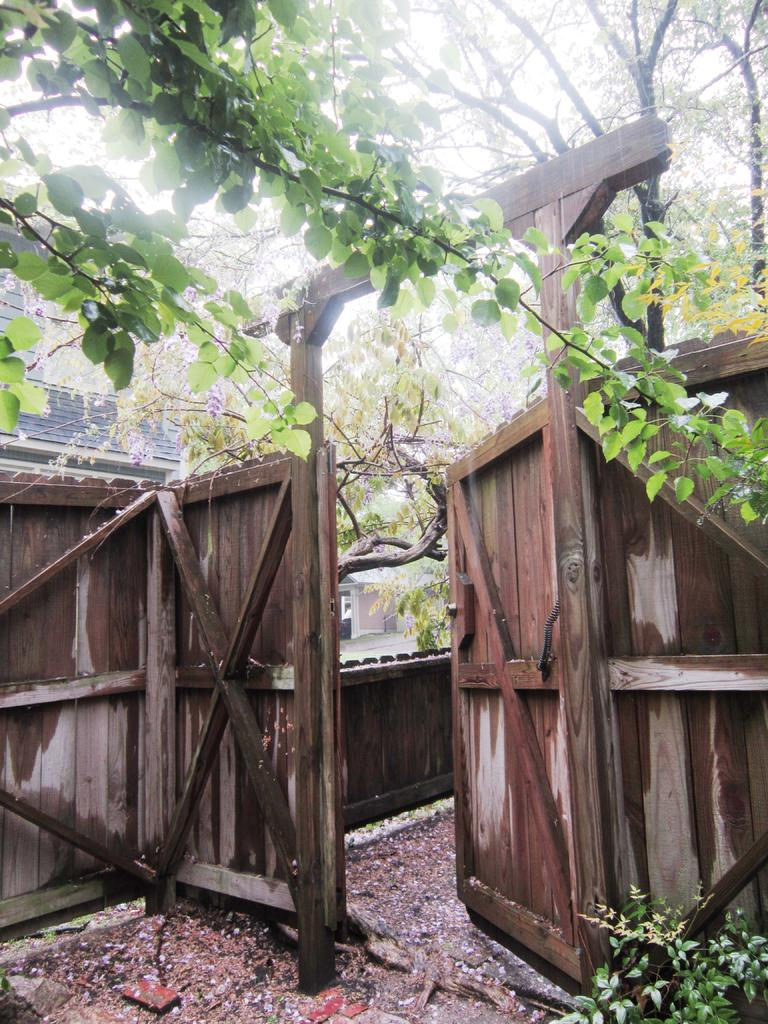What type of structure is present in the image? There is a wooden arch in the image. What other wooden structures can be seen in the image? There is a wooden fence and a wooden door in the image. What type of natural elements are visible in the image? There are trees visible in the image. What type of horn can be heard in the image? There is no horn present in the image, and therefore no sound can be heard. 